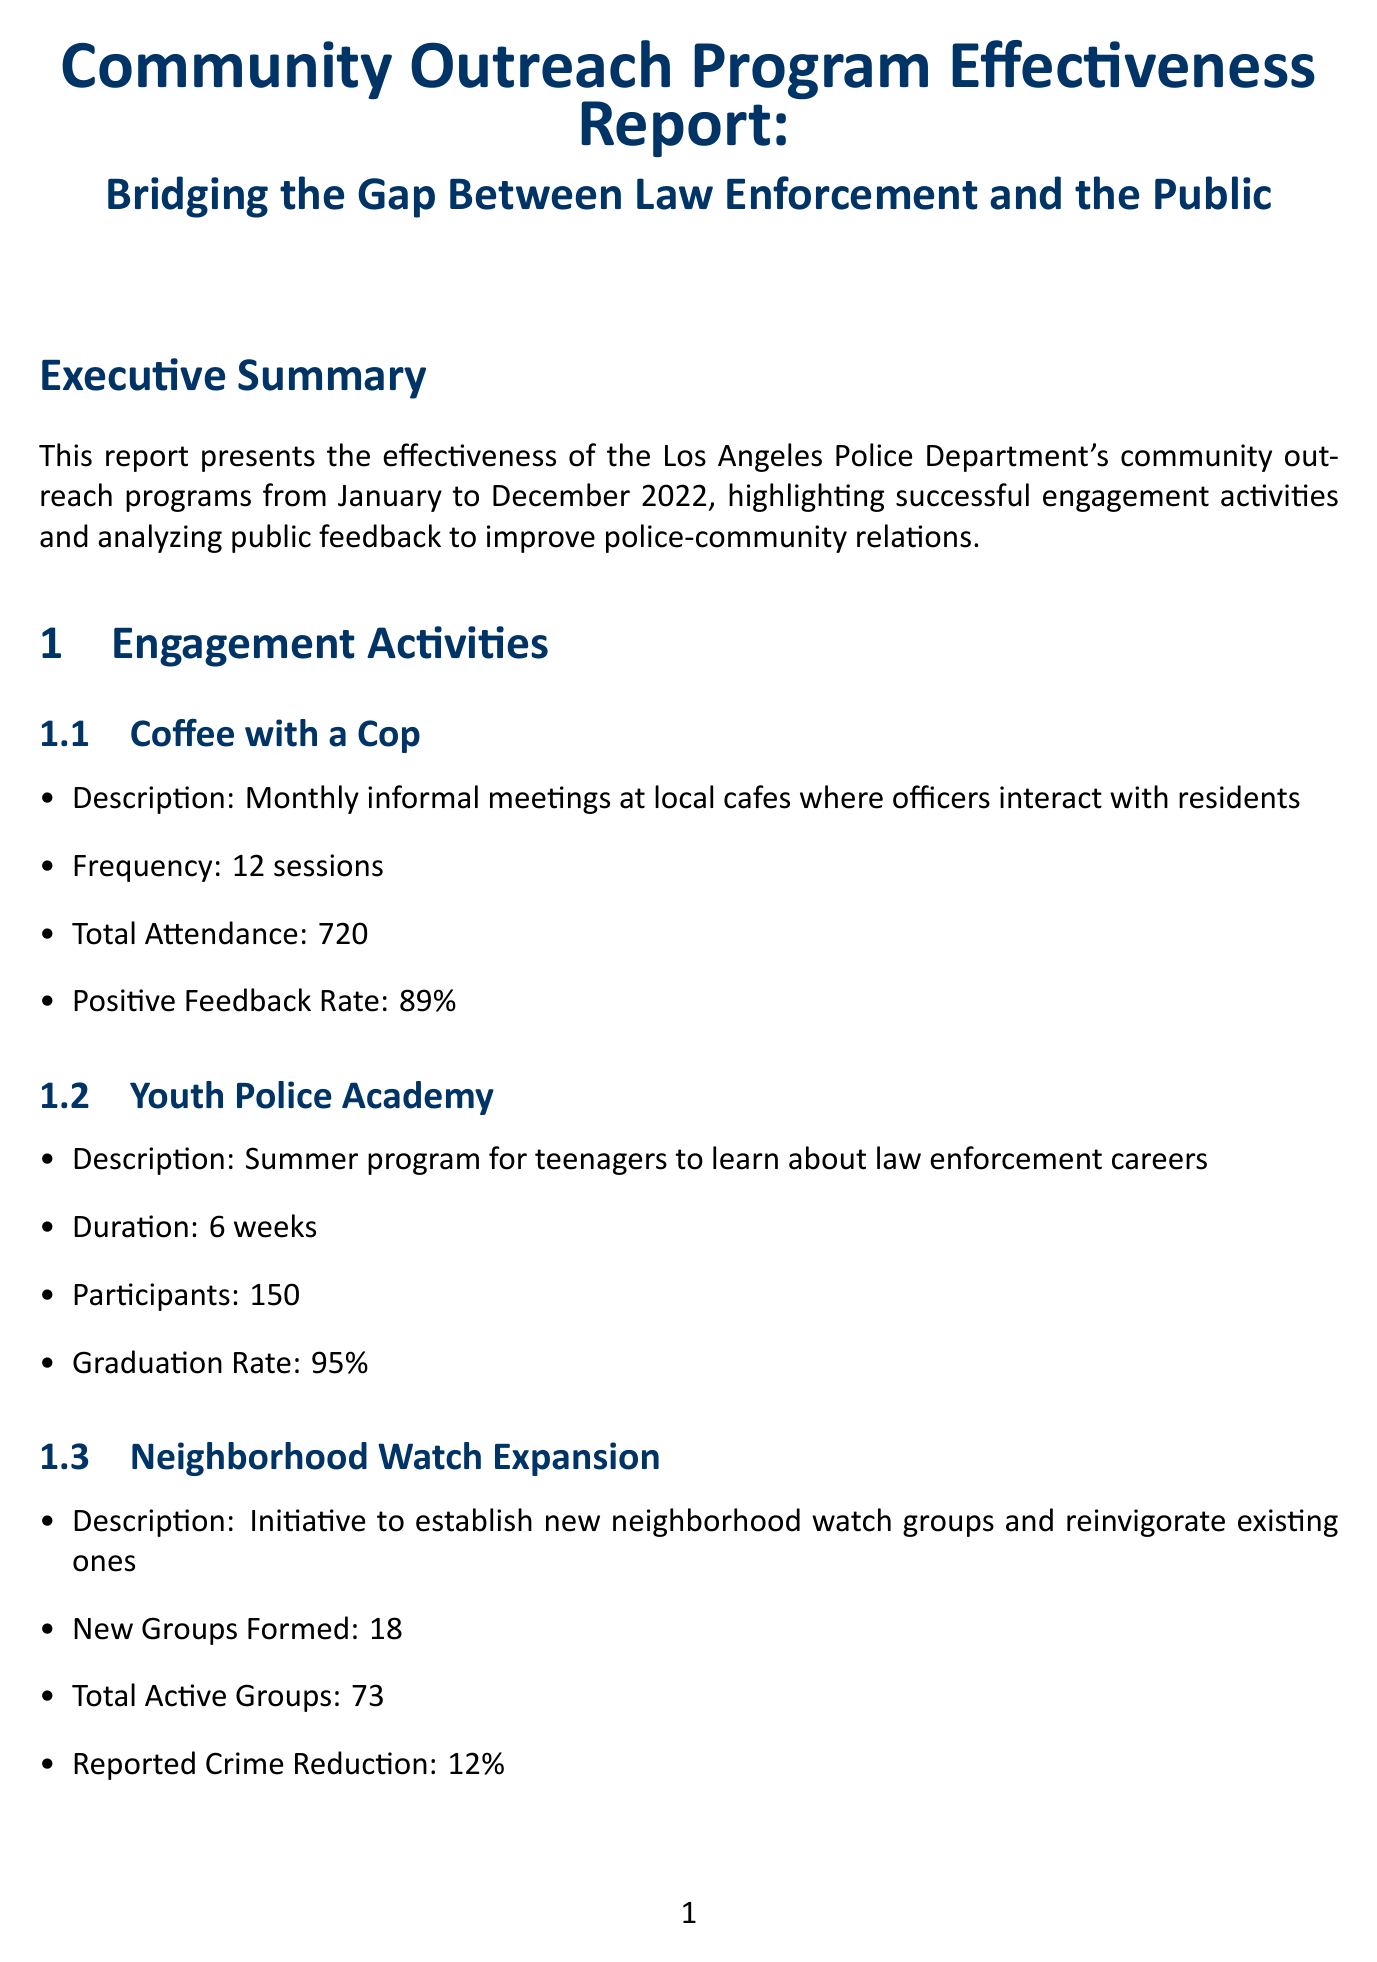What is the overall satisfaction rate from the survey? The overall satisfaction is stated as 74% satisfied or very satisfied from the public feedback section in the report.
Answer: 74% How many sessions were held for "Coffee with a Cop"? The frequency of the "Coffee with a Cop" sessions is mentioned as 12 sessions in the engagement activities.
Answer: 12 sessions What was the graduation rate for the Youth Police Academy? The graduation rate for the Youth Police Academy program is provided as 95%, corresponding to the engagement activities.
Answer: 95% What is one area of improvement identified in the public feedback section? The document lists areas of improvement, one of which is "Response time to non-emergency calls."
Answer: Response time to non-emergency calls How many positive articles were published about the outreach program? The media coverage section specifies that there were 28 positive articles published.
Answer: 28 What benefits have been observed from the community outreach programs? The document enumerates benefits, one of which is "Increased trust between officers and community members."
Answer: Increased trust between officers and community members How many total attendees participated in the "Coffee with a Cop" program? The total attendance for the "Coffee with a Cop" program over 12 sessions is reported as 720 attendees.
Answer: 720 What recommendation is made regarding social media? The report recommends increasing social media presence to showcase positive police-community interactions.
Answer: Increase social media presence What was the reported crime reduction percentage from the Neighborhood Watch Expansion? The reported crime reduction from the Neighborhood Watch Expansion initiative is recorded as 12%.
Answer: 12% 